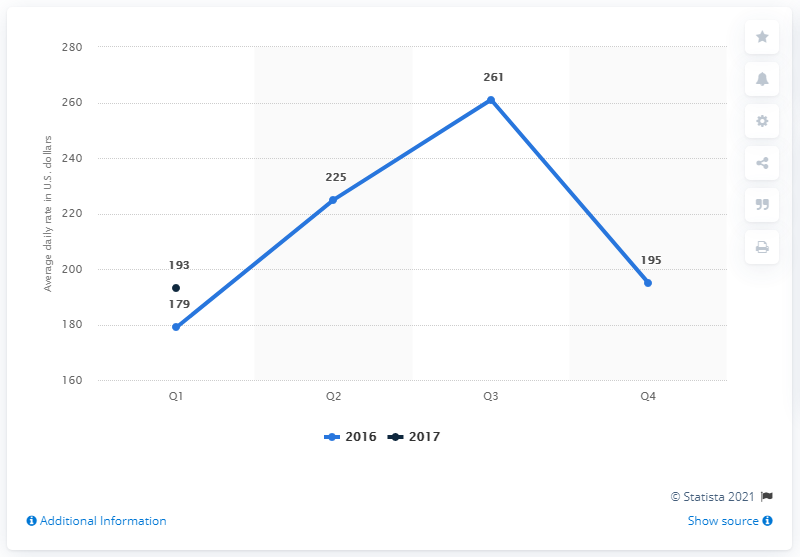List a handful of essential elements in this visual. According to data from the first quarter of 2017, the average daily rate for hotels in Seattle, United States was approximately 193 US dollars. 